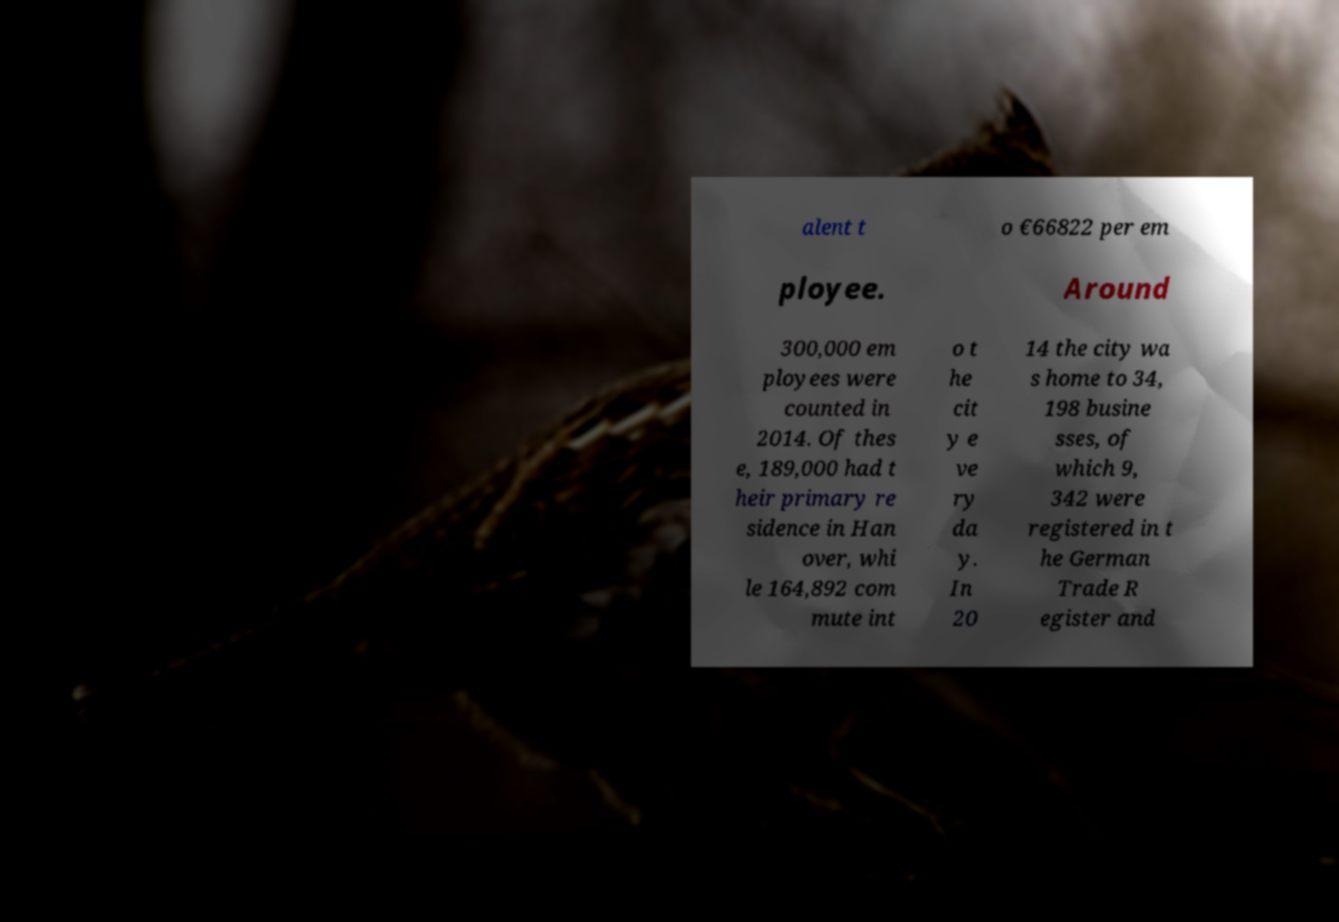What messages or text are displayed in this image? I need them in a readable, typed format. alent t o €66822 per em ployee. Around 300,000 em ployees were counted in 2014. Of thes e, 189,000 had t heir primary re sidence in Han over, whi le 164,892 com mute int o t he cit y e ve ry da y. In 20 14 the city wa s home to 34, 198 busine sses, of which 9, 342 were registered in t he German Trade R egister and 